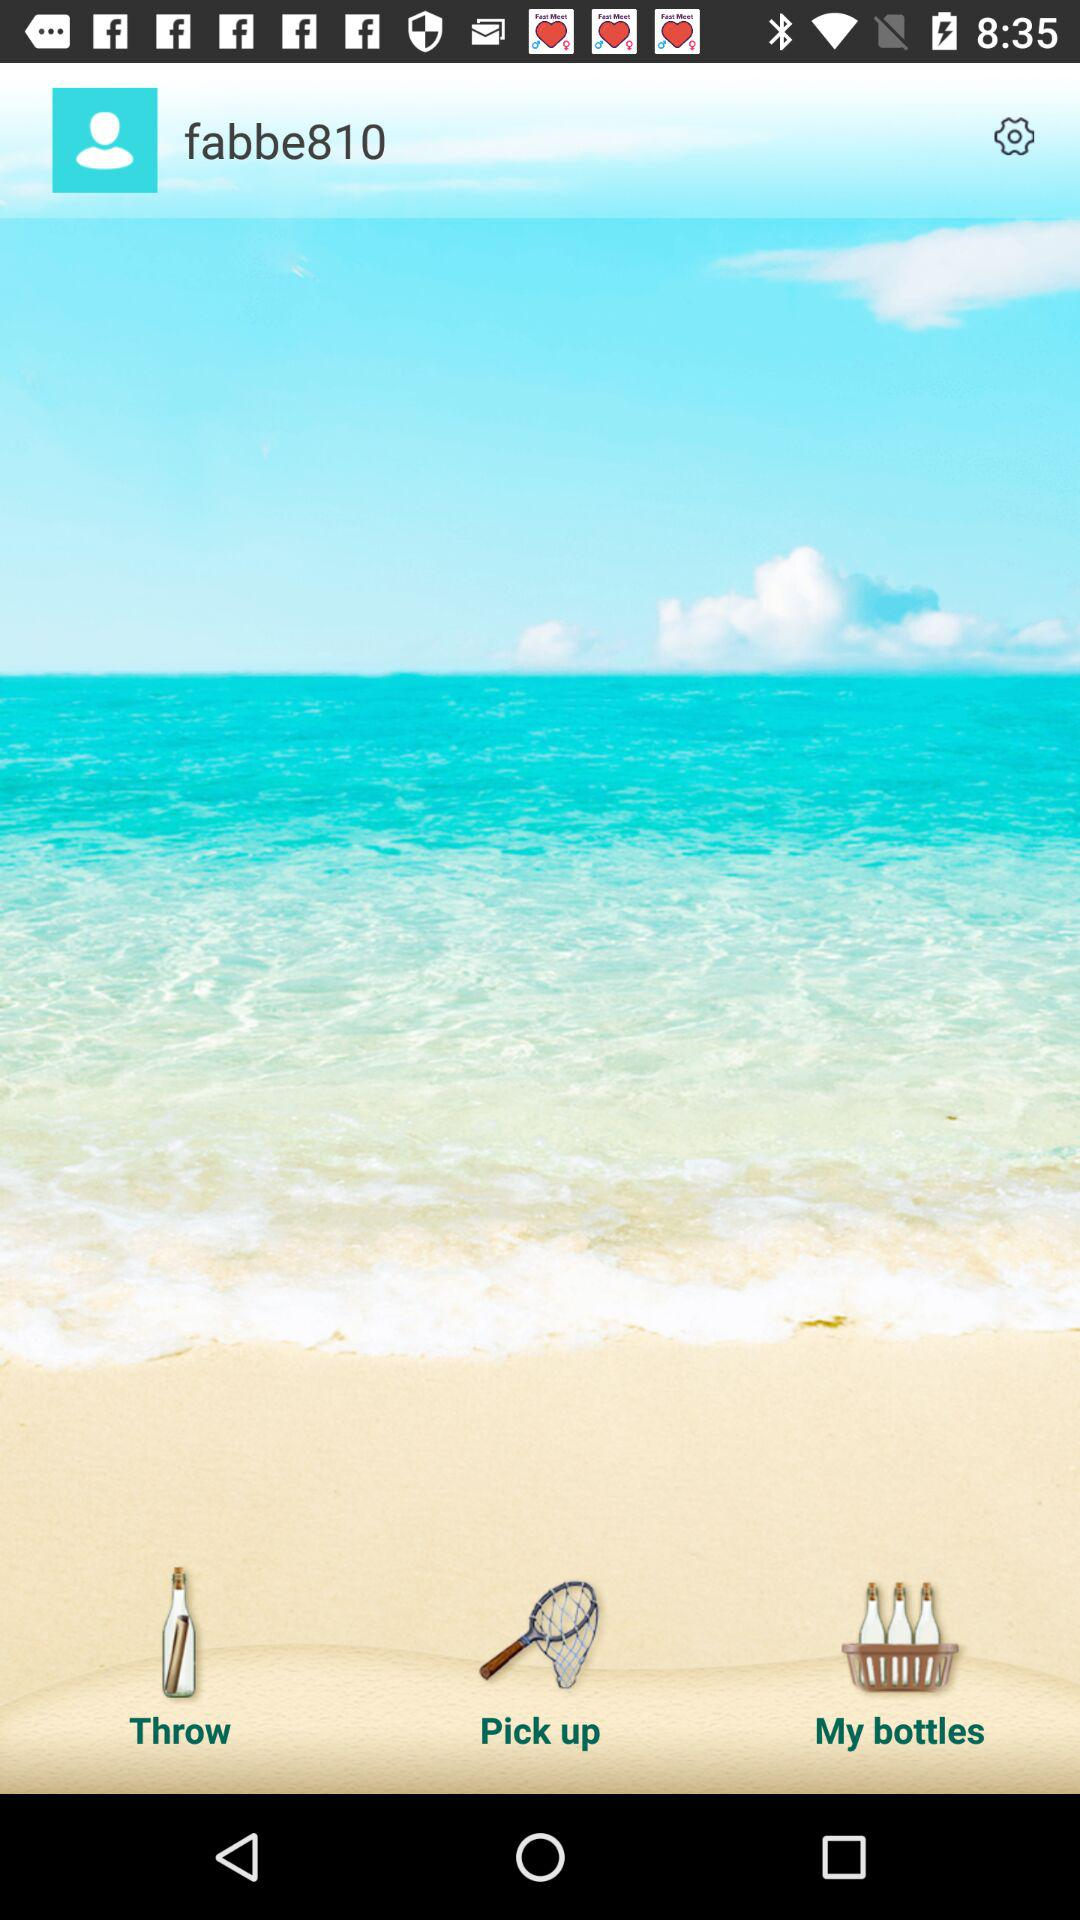What is the user name? The user name is "fabbe810". 